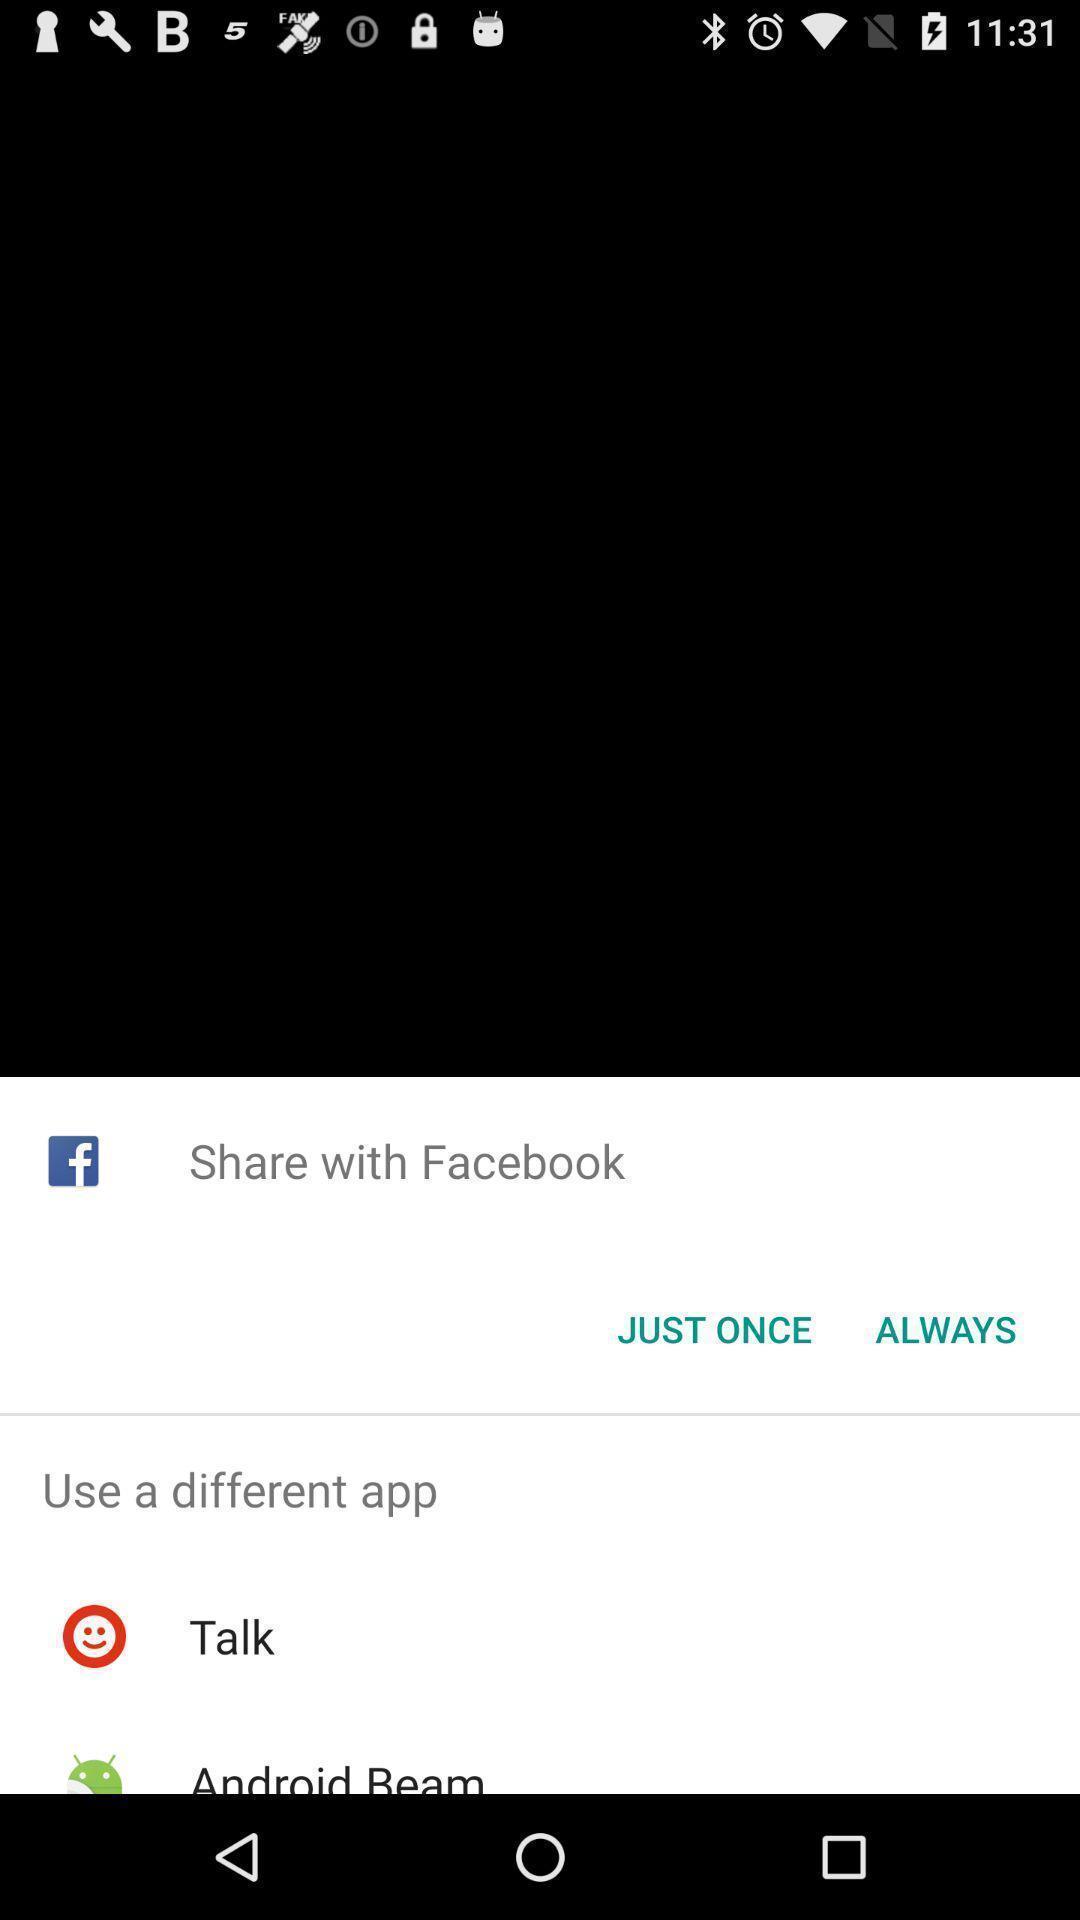Tell me about the visual elements in this screen capture. Popup displaying confirmation to open a file. 